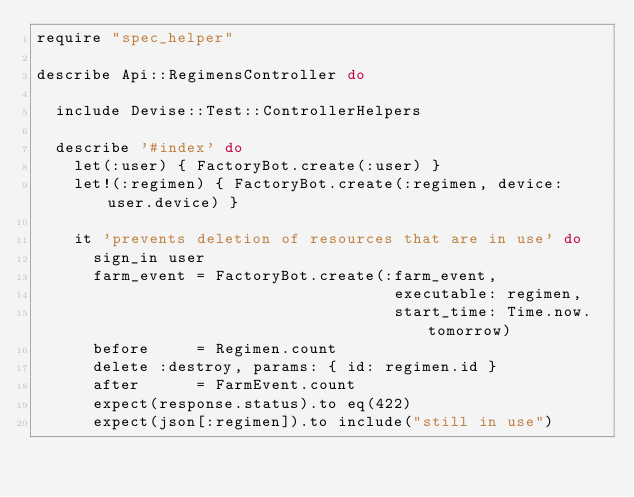Convert code to text. <code><loc_0><loc_0><loc_500><loc_500><_Ruby_>require "spec_helper"

describe Api::RegimensController do

  include Devise::Test::ControllerHelpers

  describe '#index' do
    let(:user) { FactoryBot.create(:user) }
    let!(:regimen) { FactoryBot.create(:regimen, device: user.device) }

    it 'prevents deletion of resources that are in use' do
      sign_in user
      farm_event = FactoryBot.create(:farm_event,
                                      executable: regimen,
                                      start_time: Time.now.tomorrow)
      before     = Regimen.count
      delete :destroy, params: { id: regimen.id }
      after      = FarmEvent.count
      expect(response.status).to eq(422)
      expect(json[:regimen]).to include("still in use")</code> 